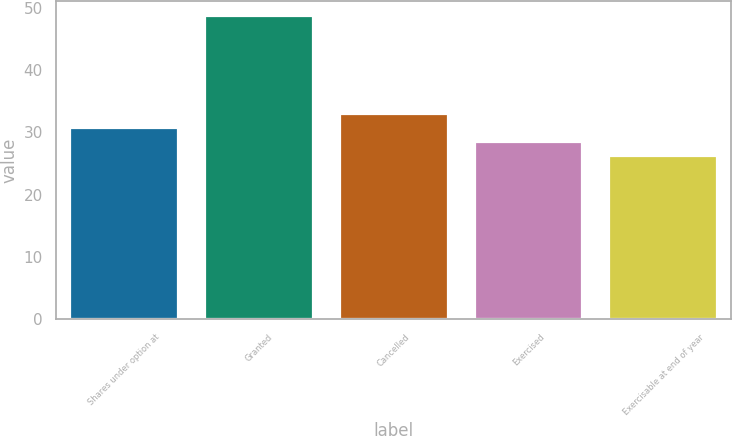<chart> <loc_0><loc_0><loc_500><loc_500><bar_chart><fcel>Shares under option at<fcel>Granted<fcel>Cancelled<fcel>Exercised<fcel>Exercisable at end of year<nl><fcel>30.65<fcel>48.59<fcel>32.89<fcel>28.41<fcel>26.17<nl></chart> 